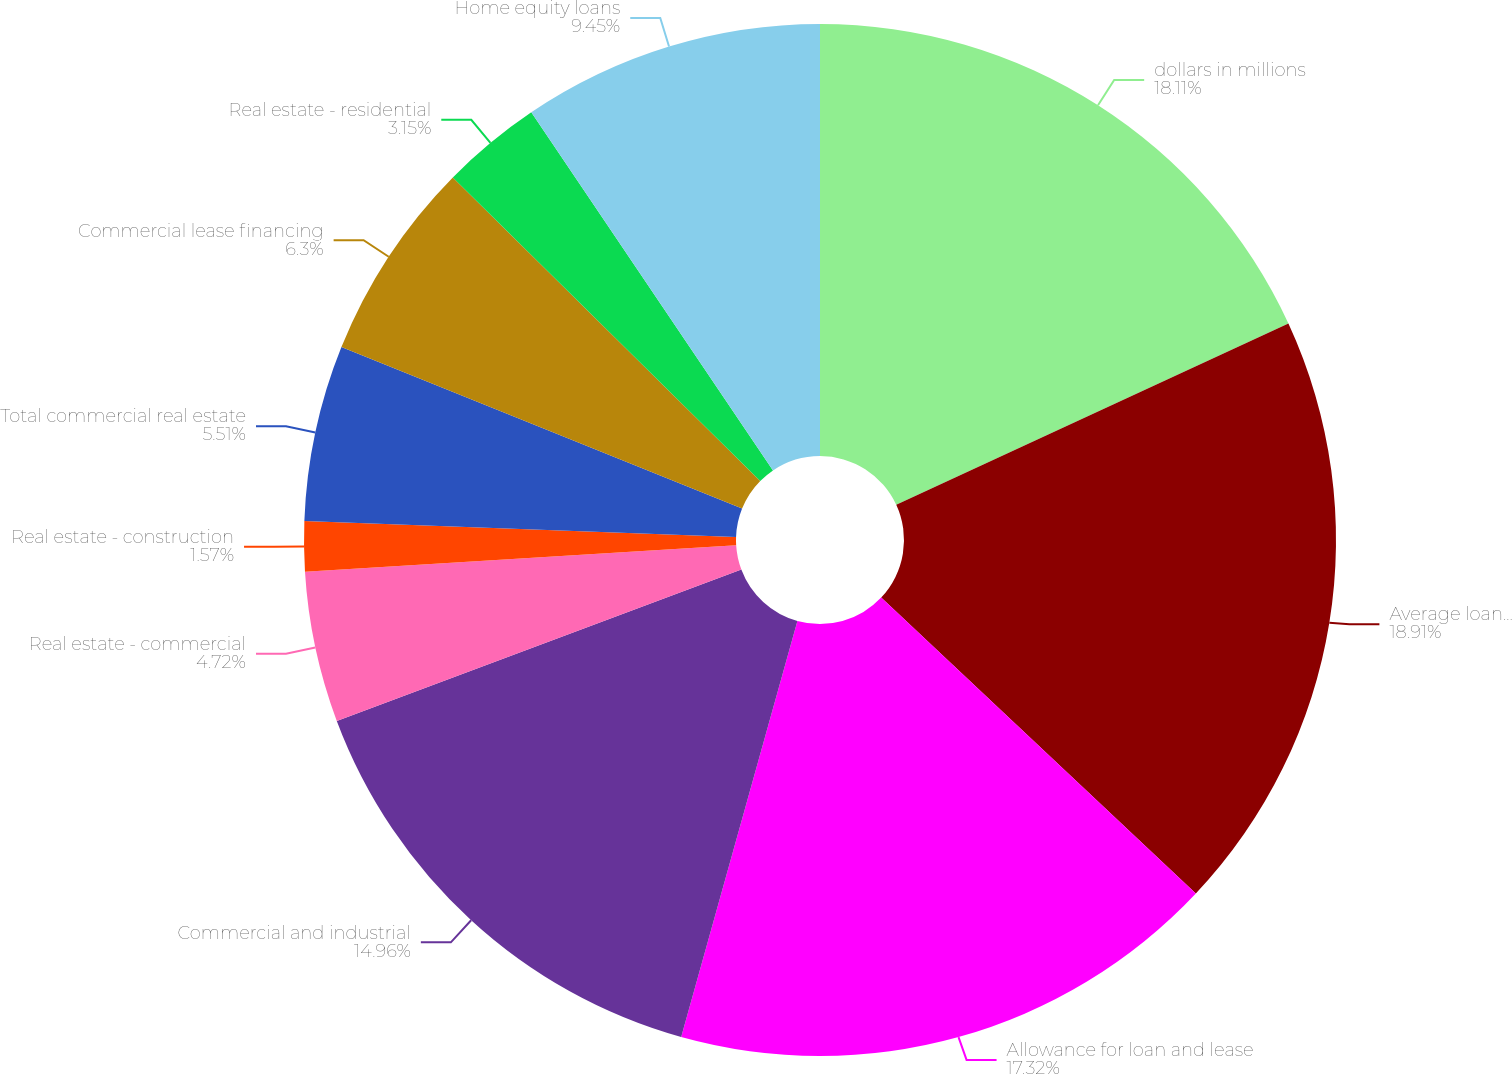<chart> <loc_0><loc_0><loc_500><loc_500><pie_chart><fcel>dollars in millions<fcel>Average loans outstanding<fcel>Allowance for loan and lease<fcel>Commercial and industrial<fcel>Real estate - commercial<fcel>Real estate - construction<fcel>Total commercial real estate<fcel>Commercial lease financing<fcel>Real estate - residential<fcel>Home equity loans<nl><fcel>18.11%<fcel>18.9%<fcel>17.32%<fcel>14.96%<fcel>4.72%<fcel>1.57%<fcel>5.51%<fcel>6.3%<fcel>3.15%<fcel>9.45%<nl></chart> 